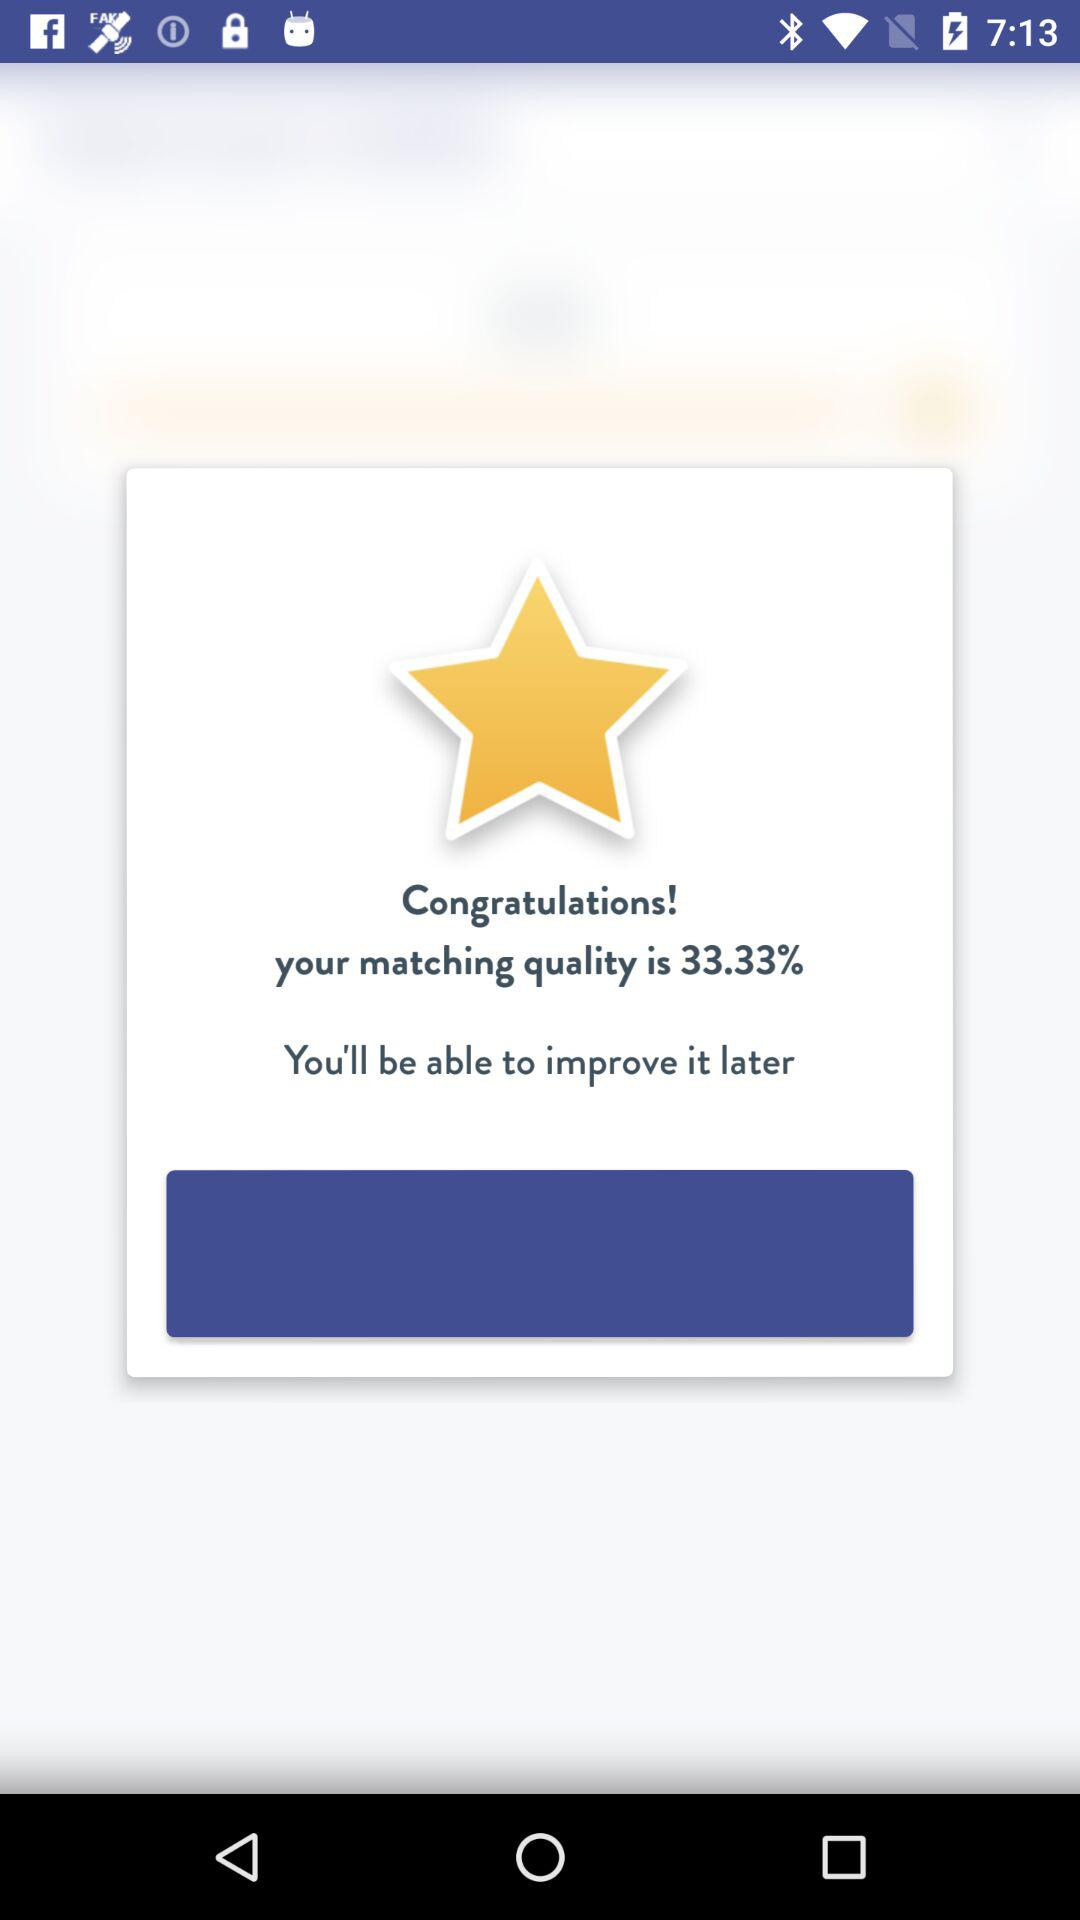What is the matching quality? The matching quality is 33.33%. 